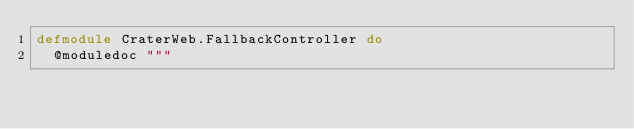Convert code to text. <code><loc_0><loc_0><loc_500><loc_500><_Elixir_>defmodule CraterWeb.FallbackController do
  @moduledoc """</code> 